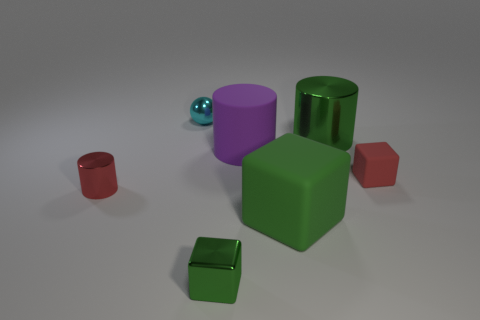Add 1 large purple rubber things. How many objects exist? 8 Subtract all cylinders. How many objects are left? 4 Subtract all big purple rubber cylinders. Subtract all metal things. How many objects are left? 2 Add 7 red things. How many red things are left? 9 Add 3 green metallic cylinders. How many green metallic cylinders exist? 4 Subtract 0 purple cubes. How many objects are left? 7 